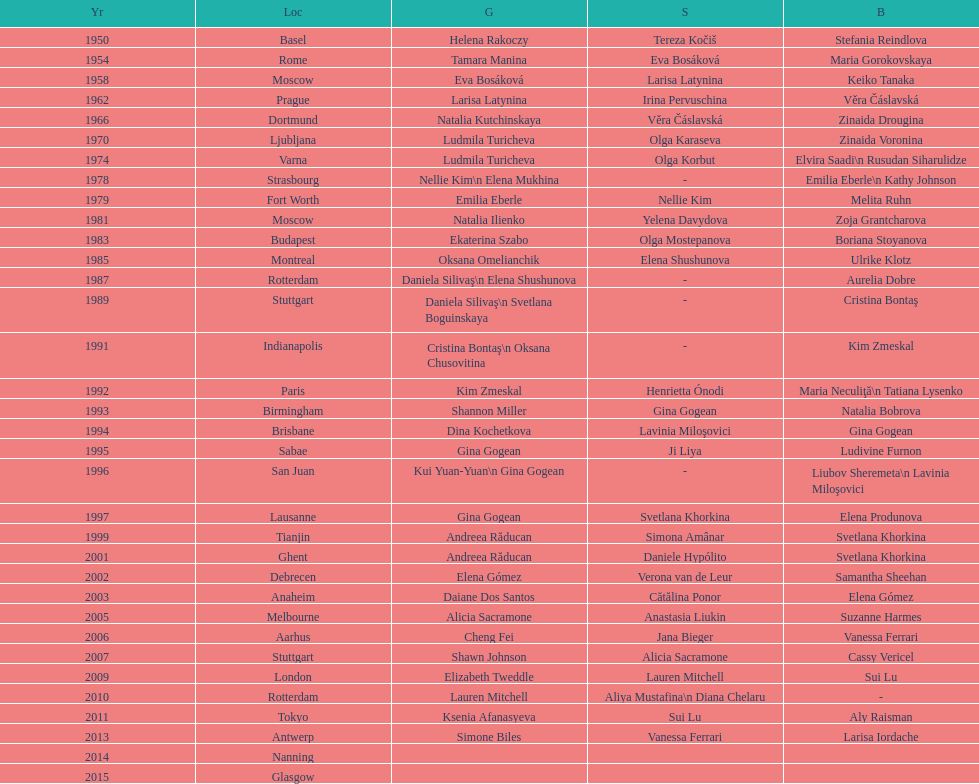What is the count of medals won by brazilians? 2. 